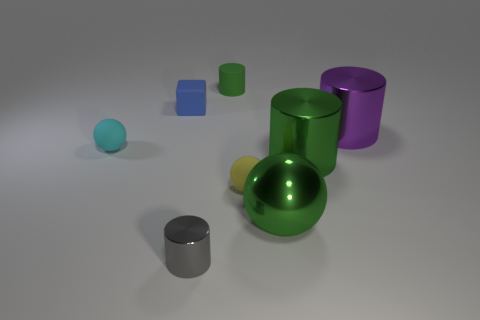Are the surfaces of all the objects equally smooth? While all the objects appear to have smooth surfaces, upon closer inspection, the blue cube's surface seems slightly less reflective, possibly indicating a slightly rougher texture compared to the high sheen on the other objects. 